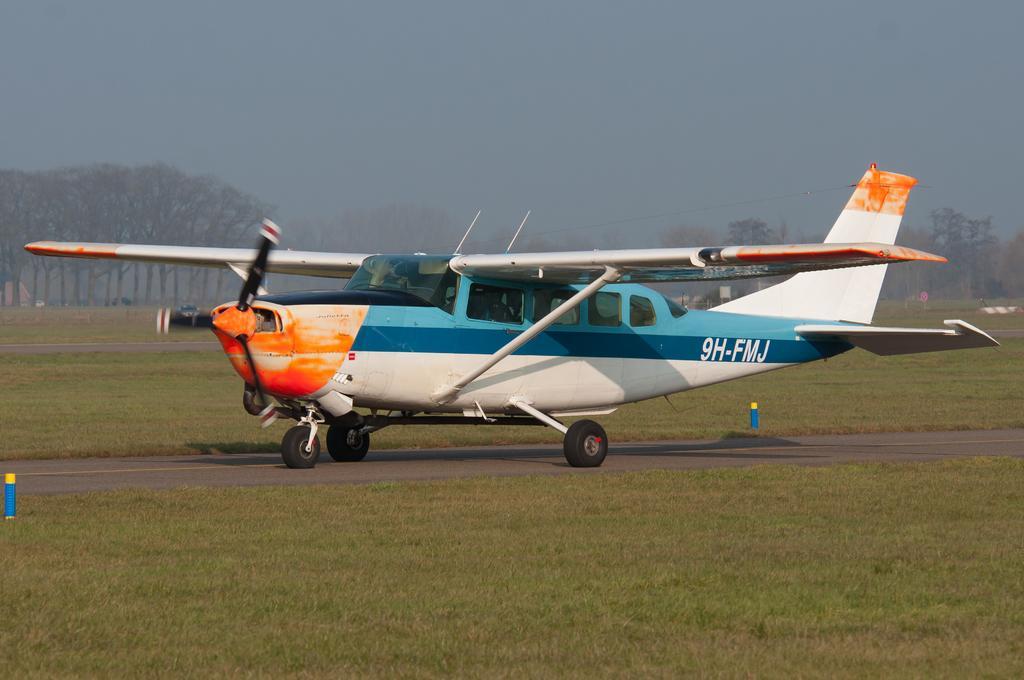Could you give a brief overview of what you see in this image? In this picture there is an aircraft in the center of the image and there is grassland in the image and there are trees in the background area of the image. 